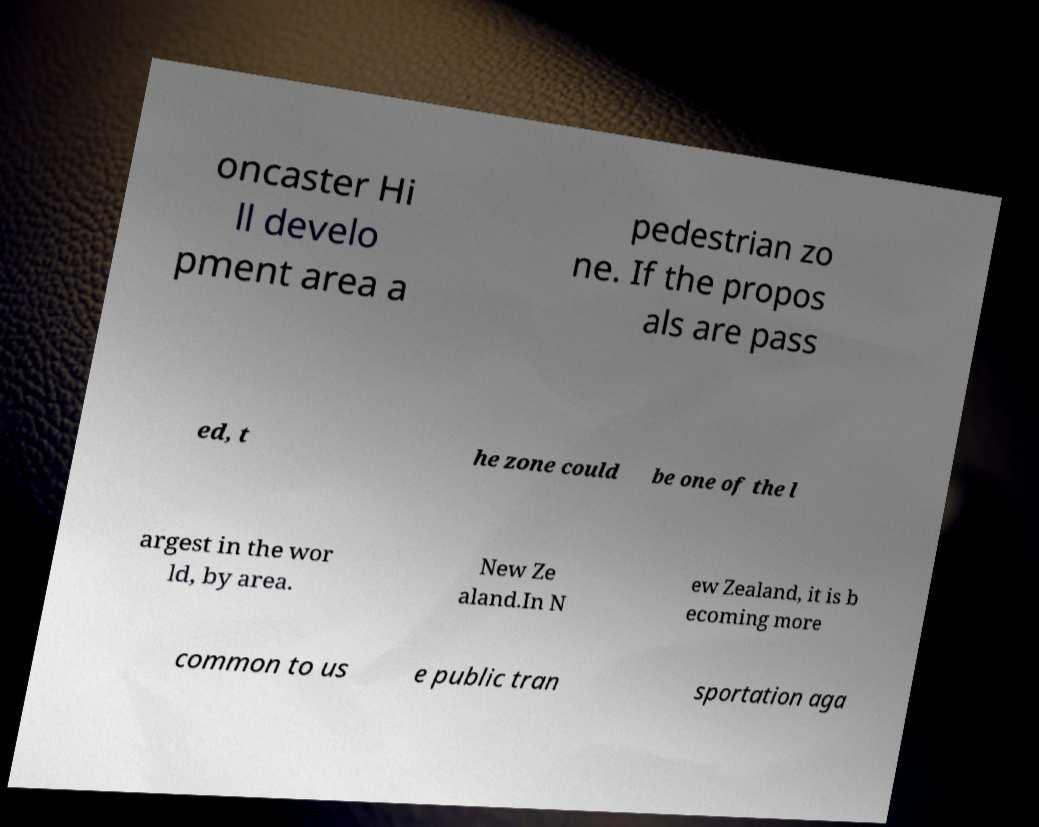There's text embedded in this image that I need extracted. Can you transcribe it verbatim? oncaster Hi ll develo pment area a pedestrian zo ne. If the propos als are pass ed, t he zone could be one of the l argest in the wor ld, by area. New Ze aland.In N ew Zealand, it is b ecoming more common to us e public tran sportation aga 